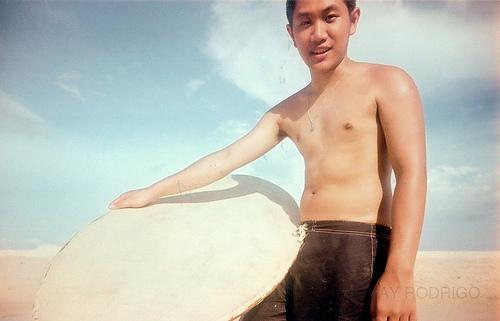Question: what is the person carrying?
Choices:
A. Sun tan lotion.
B. Surfboard.
C. Goggles.
D. His shirt.
Answer with the letter. Answer: B Question: what color is the surfboard?
Choices:
A. White.
B. Cream.
C. Alabaster.
D. Beige.
Answer with the letter. Answer: A Question: what is the person wearing around his neck?
Choices:
A. Necklace.
B. Scarf.
C. Chain.
D. Turtle neck shirt.
Answer with the letter. Answer: C 